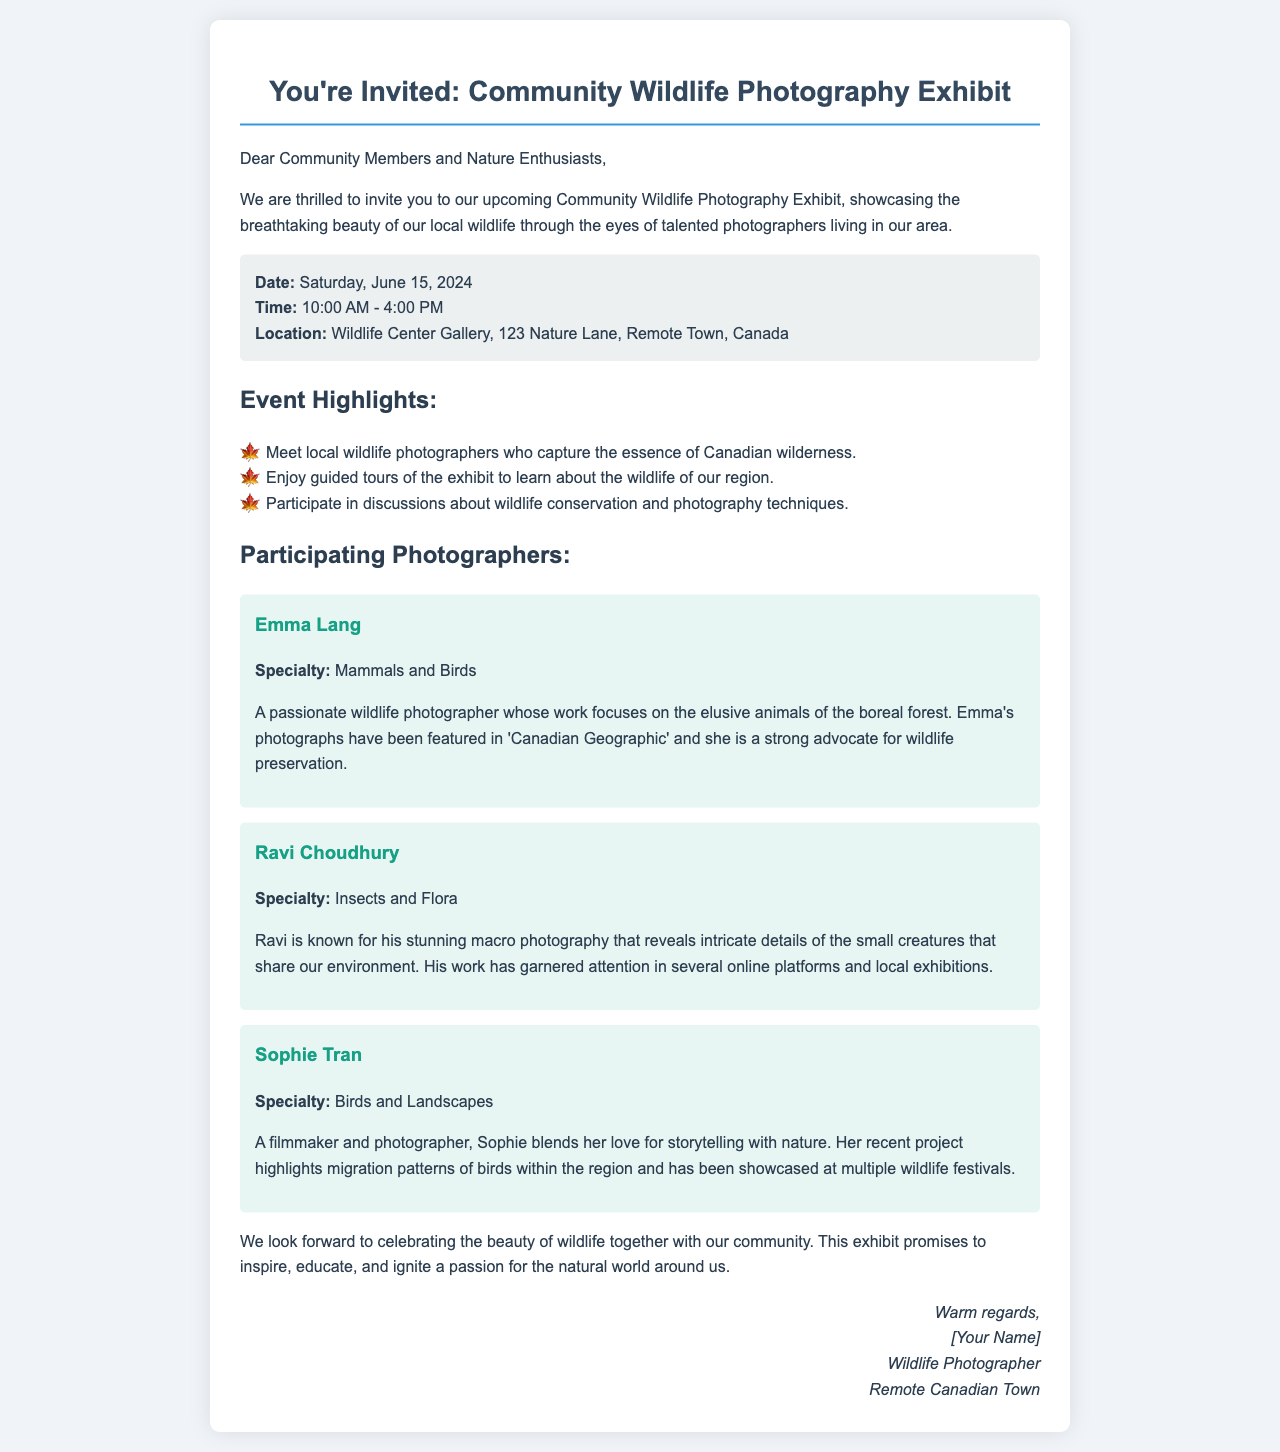What is the date of the exhibit? The date of the exhibit is mentioned in the event details section of the document.
Answer: Saturday, June 15, 2024 What time does the exhibit start? The time for the start of the exhibit is found in the event details section.
Answer: 10:00 AM Where is the exhibit taking place? The location of the exhibit is specified in the event details section.
Answer: Wildlife Center Gallery, 123 Nature Lane, Remote Town, Canada Who specializes in Mammals and Birds? This specialty is listed in the profiles of the participating photographers.
Answer: Emma Lang What are the event highlights? The highlights are outlined in a specific section, showcasing different aspects of the event.
Answer: Meet local wildlife photographers who capture the essence of Canadian wilderness How many photographers are mentioned as participating? The number of photographers can be counted from their listed profiles in the document.
Answer: Three Which photographer is known for macro photography? This specialty is mentioned in the profile highlights of the photographers.
Answer: Ravi Choudhury What is the overall purpose of the exhibit? The purpose is articulated in the closing remarks of the document.
Answer: Inspire, educate, and ignite a passion for the natural world around us 